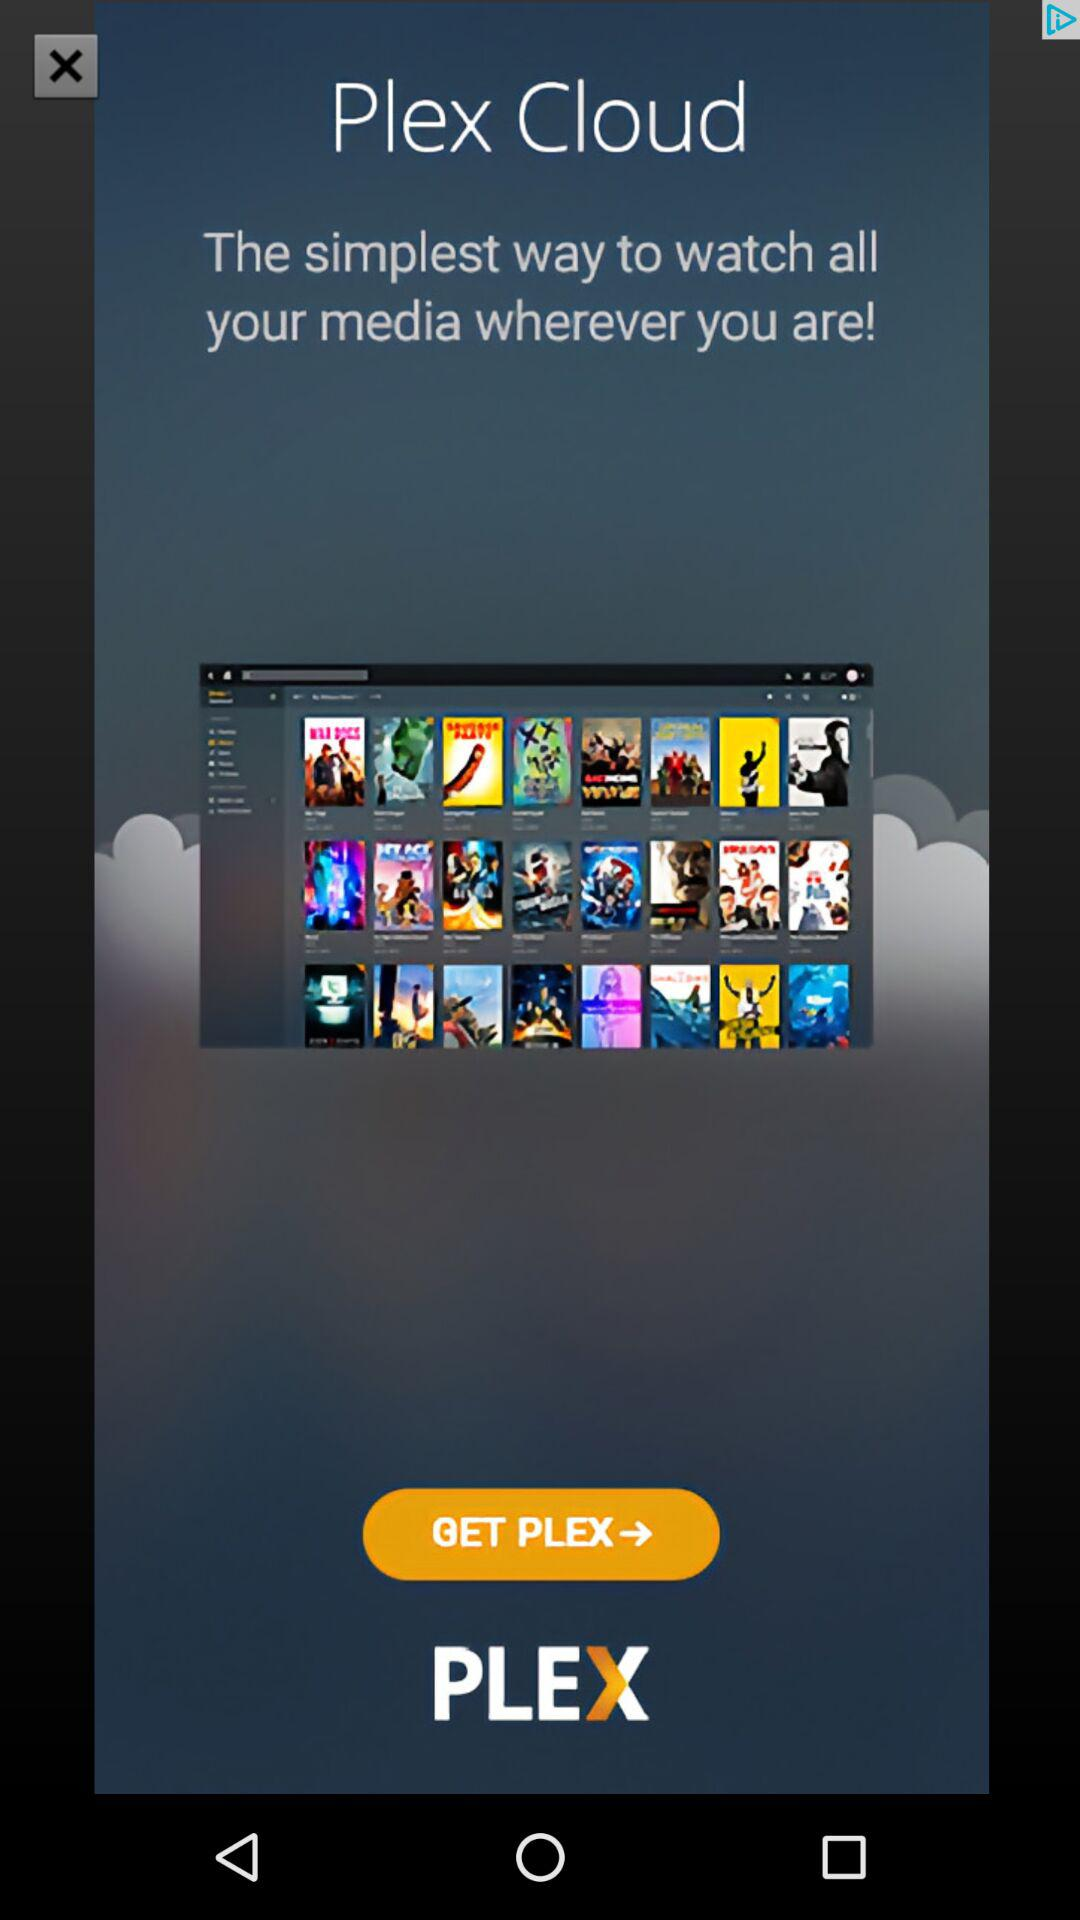What is the name of the application? The name of the application is "Plex". 